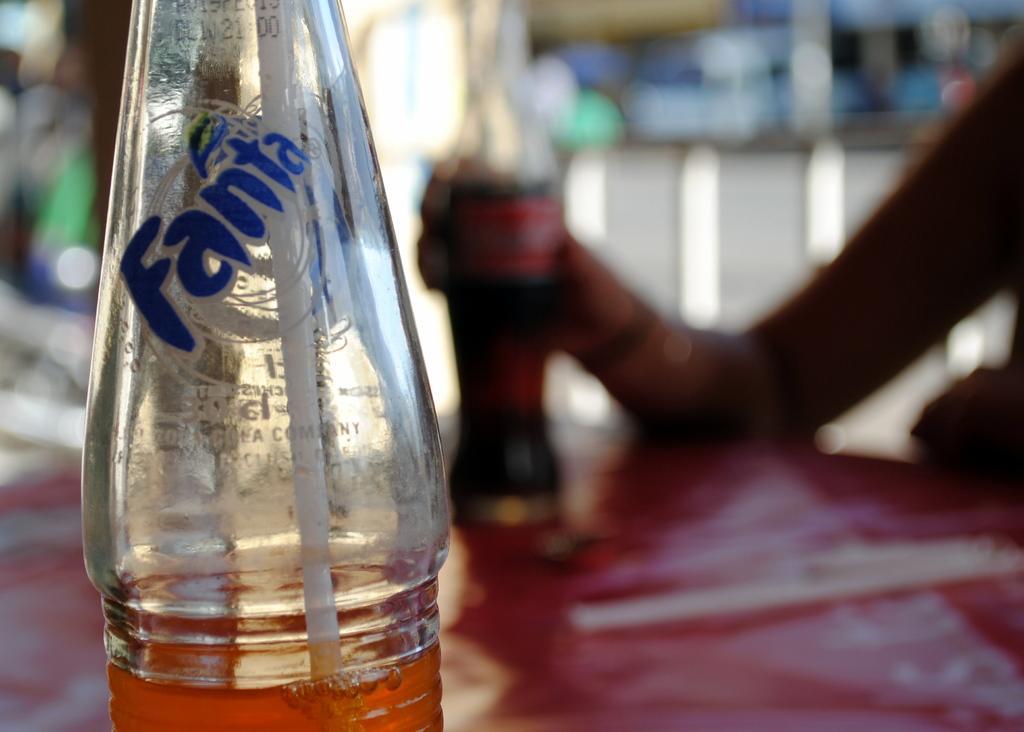Could you give a brief overview of what you see in this image? In the left it's a Fanta bottle and there is a straw in it. In the right side a person is sitting and holding a coke bottle. 